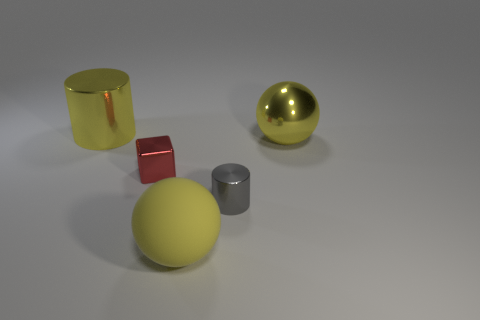Add 2 small gray cylinders. How many objects exist? 7 Subtract all cubes. How many objects are left? 4 Add 3 yellow things. How many yellow things exist? 6 Subtract 0 blue spheres. How many objects are left? 5 Subtract all yellow cylinders. Subtract all cyan shiny cylinders. How many objects are left? 4 Add 1 shiny cubes. How many shiny cubes are left? 2 